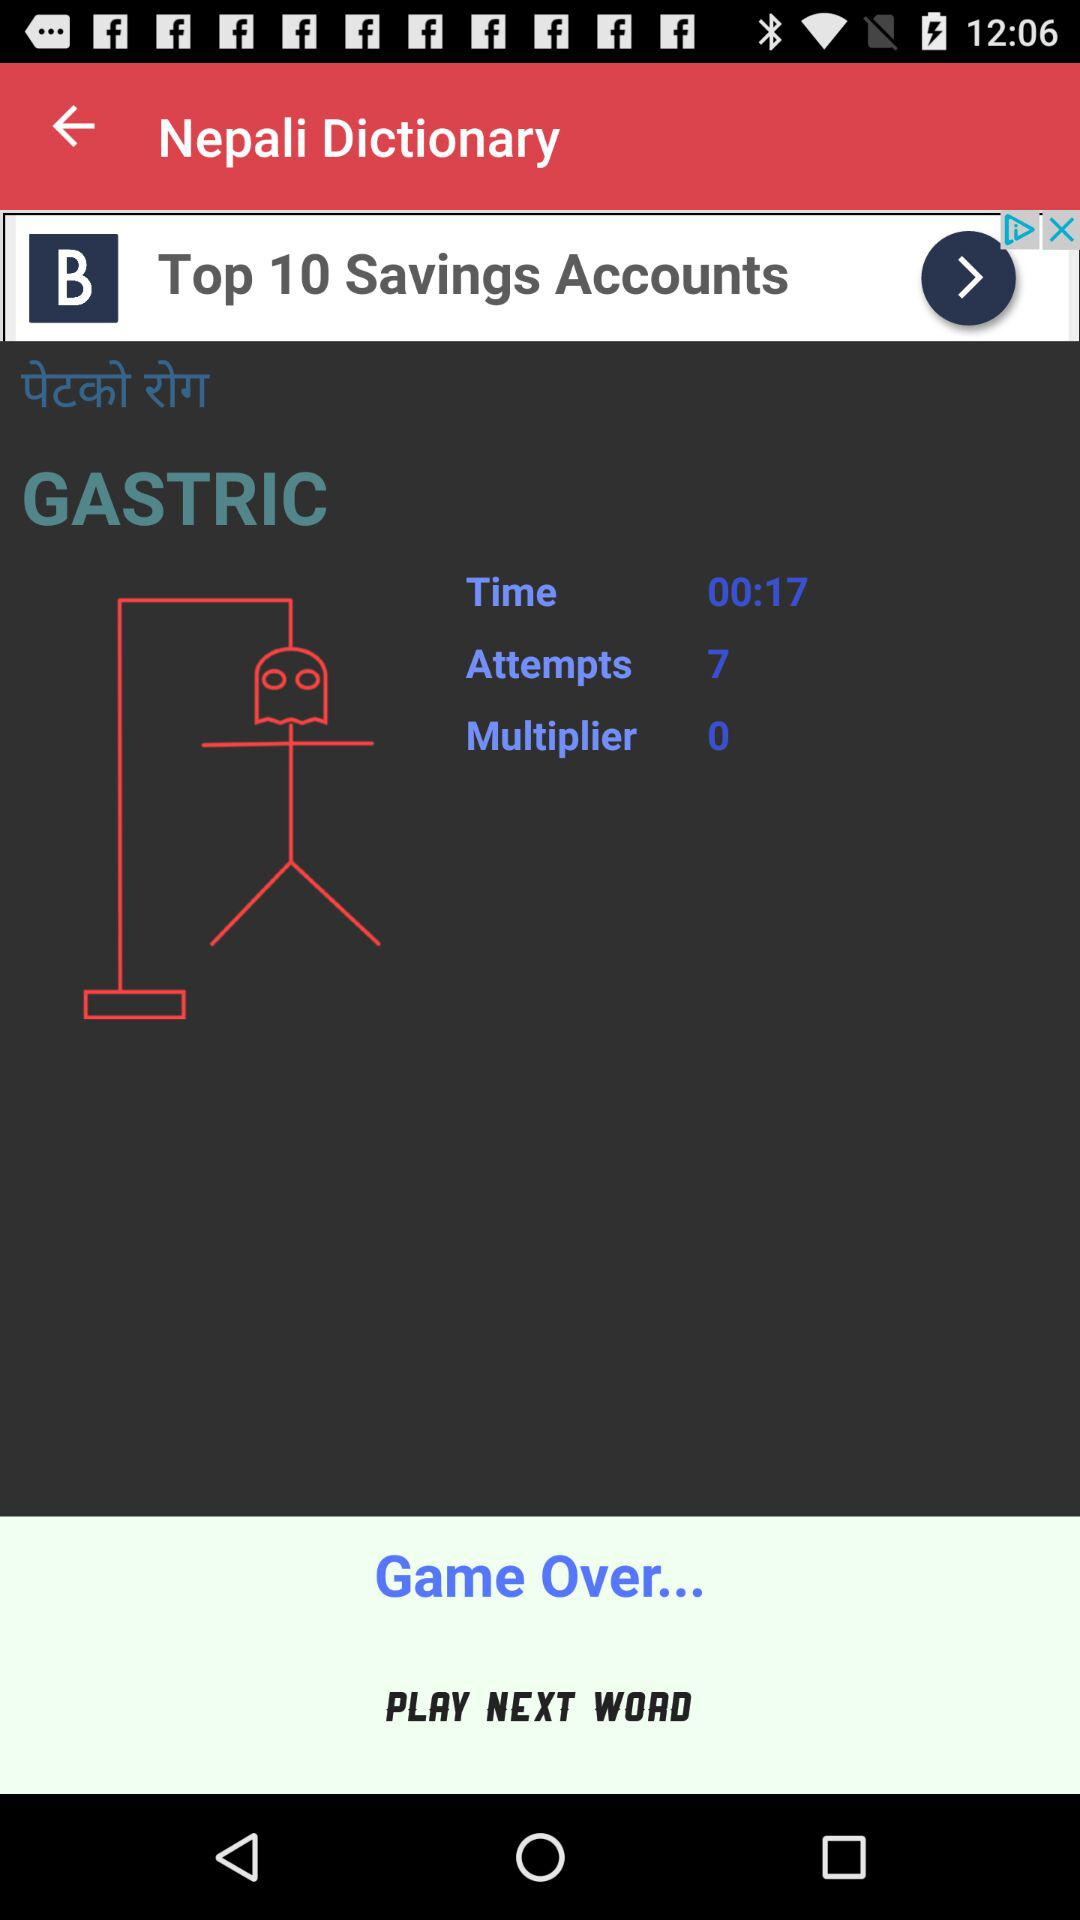What is the multiplier? The multiplier is 0. 